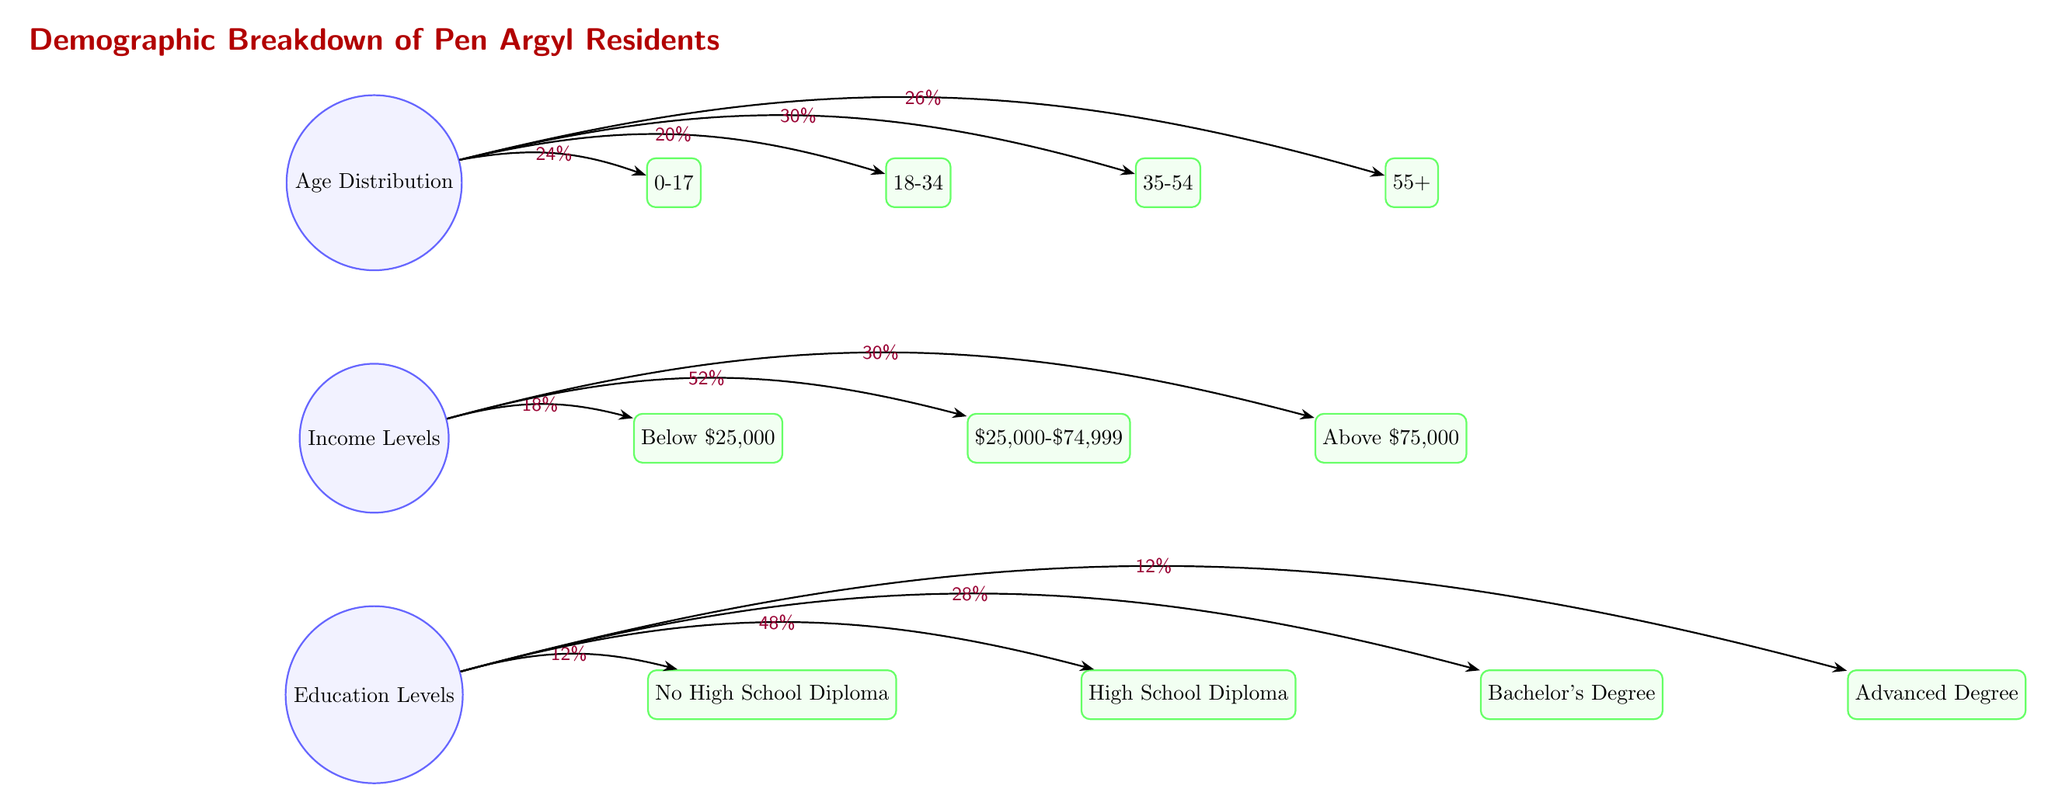What percentage of Pen Argyl residents are aged 0-17? The diagram shows that 24% of the residents fall within the 0-17 age group, as indicated by the label on the edge connecting the "Age Distribution" node to the "0-17" node.
Answer: 24% What is the total percentage of residents with a high school diploma or higher? The categories for education levels include "High School Diploma" (48%), "Bachelor's Degree" (28%), and "Advanced Degree" (12%). Adding these percentages gives 48% + 28% + 12% = 88%.
Answer: 88% How many distinct age groups are represented in the diagram? The diagram includes four age groups: 0-17, 18-34, 35-54, and 55+. Therefore, there are four distinct age groups represented.
Answer: 4 What is the income group with the highest percentage? The income distribution shows three groups: Below $25,000 (18%), $25,000-$74,999 (52%), and Above $75,000 (30%). The highest percentage is for the $25,000-$74,999 group, which is 52%.
Answer: $25,000-$74,999 What is the percentage of Pen Argyl residents with an advanced degree relative to those with a high school diploma? The percentage of residents with an advanced degree is 12%, while those with a high school diploma is 48%. To find the relative percentage, we compare these two figures: 12% is one-fourth of 48%, indicating a significant difference.
Answer: 12% 